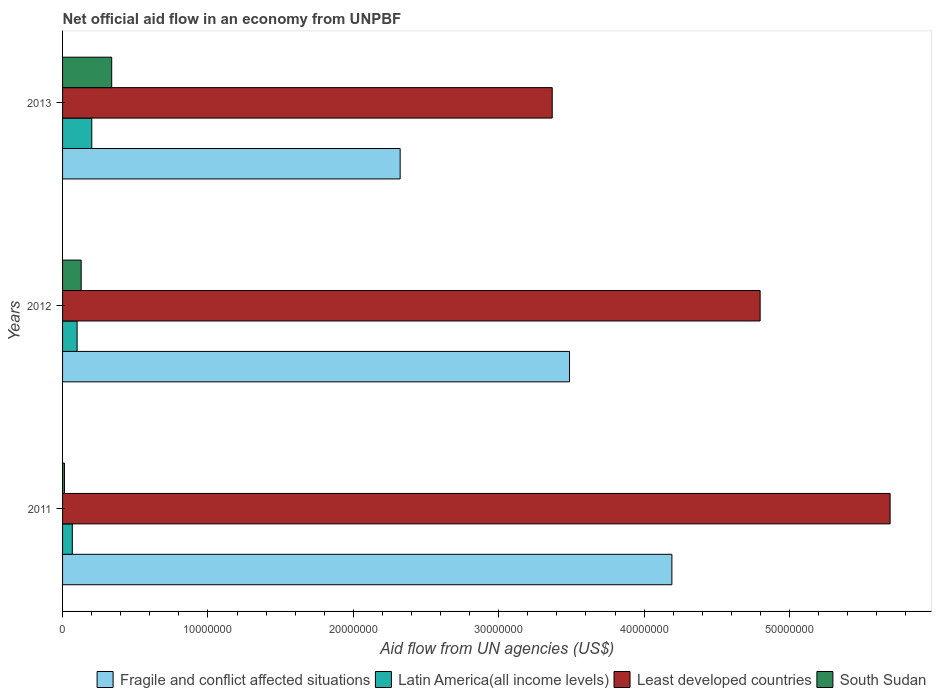Are the number of bars per tick equal to the number of legend labels?
Your answer should be compact. Yes. Are the number of bars on each tick of the Y-axis equal?
Provide a succinct answer. Yes. How many bars are there on the 2nd tick from the top?
Keep it short and to the point. 4. What is the label of the 2nd group of bars from the top?
Provide a short and direct response. 2012. In how many cases, is the number of bars for a given year not equal to the number of legend labels?
Provide a succinct answer. 0. What is the net official aid flow in Fragile and conflict affected situations in 2012?
Your answer should be very brief. 3.49e+07. Across all years, what is the maximum net official aid flow in South Sudan?
Provide a succinct answer. 3.38e+06. Across all years, what is the minimum net official aid flow in Fragile and conflict affected situations?
Your answer should be compact. 2.32e+07. In which year was the net official aid flow in South Sudan maximum?
Provide a succinct answer. 2013. In which year was the net official aid flow in Latin America(all income levels) minimum?
Keep it short and to the point. 2011. What is the total net official aid flow in South Sudan in the graph?
Make the answer very short. 4.79e+06. What is the difference between the net official aid flow in Fragile and conflict affected situations in 2011 and that in 2012?
Your response must be concise. 7.04e+06. What is the difference between the net official aid flow in Fragile and conflict affected situations in 2011 and the net official aid flow in Latin America(all income levels) in 2012?
Your answer should be compact. 4.09e+07. What is the average net official aid flow in Fragile and conflict affected situations per year?
Keep it short and to the point. 3.33e+07. In the year 2012, what is the difference between the net official aid flow in Least developed countries and net official aid flow in Latin America(all income levels)?
Your answer should be compact. 4.70e+07. What is the ratio of the net official aid flow in Latin America(all income levels) in 2012 to that in 2013?
Your answer should be compact. 0.5. What is the difference between the highest and the second highest net official aid flow in Latin America(all income levels)?
Ensure brevity in your answer.  1.01e+06. What is the difference between the highest and the lowest net official aid flow in Fragile and conflict affected situations?
Your answer should be very brief. 1.87e+07. In how many years, is the net official aid flow in Latin America(all income levels) greater than the average net official aid flow in Latin America(all income levels) taken over all years?
Your response must be concise. 1. Is it the case that in every year, the sum of the net official aid flow in Fragile and conflict affected situations and net official aid flow in South Sudan is greater than the sum of net official aid flow in Latin America(all income levels) and net official aid flow in Least developed countries?
Make the answer very short. Yes. What does the 2nd bar from the top in 2011 represents?
Offer a terse response. Least developed countries. What does the 1st bar from the bottom in 2012 represents?
Your answer should be compact. Fragile and conflict affected situations. Is it the case that in every year, the sum of the net official aid flow in Latin America(all income levels) and net official aid flow in South Sudan is greater than the net official aid flow in Fragile and conflict affected situations?
Your answer should be very brief. No. Are all the bars in the graph horizontal?
Ensure brevity in your answer.  Yes. What is the difference between two consecutive major ticks on the X-axis?
Offer a terse response. 1.00e+07. Are the values on the major ticks of X-axis written in scientific E-notation?
Give a very brief answer. No. Does the graph contain grids?
Offer a very short reply. No. Where does the legend appear in the graph?
Make the answer very short. Bottom right. How many legend labels are there?
Make the answer very short. 4. What is the title of the graph?
Provide a short and direct response. Net official aid flow in an economy from UNPBF. Does "Czech Republic" appear as one of the legend labels in the graph?
Your response must be concise. No. What is the label or title of the X-axis?
Provide a succinct answer. Aid flow from UN agencies (US$). What is the Aid flow from UN agencies (US$) in Fragile and conflict affected situations in 2011?
Your answer should be compact. 4.19e+07. What is the Aid flow from UN agencies (US$) in Latin America(all income levels) in 2011?
Provide a succinct answer. 6.70e+05. What is the Aid flow from UN agencies (US$) of Least developed countries in 2011?
Your answer should be compact. 5.69e+07. What is the Aid flow from UN agencies (US$) in Fragile and conflict affected situations in 2012?
Your response must be concise. 3.49e+07. What is the Aid flow from UN agencies (US$) in Least developed countries in 2012?
Offer a terse response. 4.80e+07. What is the Aid flow from UN agencies (US$) of South Sudan in 2012?
Provide a succinct answer. 1.28e+06. What is the Aid flow from UN agencies (US$) in Fragile and conflict affected situations in 2013?
Your answer should be very brief. 2.32e+07. What is the Aid flow from UN agencies (US$) of Latin America(all income levels) in 2013?
Ensure brevity in your answer.  2.01e+06. What is the Aid flow from UN agencies (US$) of Least developed countries in 2013?
Offer a terse response. 3.37e+07. What is the Aid flow from UN agencies (US$) in South Sudan in 2013?
Offer a terse response. 3.38e+06. Across all years, what is the maximum Aid flow from UN agencies (US$) of Fragile and conflict affected situations?
Give a very brief answer. 4.19e+07. Across all years, what is the maximum Aid flow from UN agencies (US$) in Latin America(all income levels)?
Make the answer very short. 2.01e+06. Across all years, what is the maximum Aid flow from UN agencies (US$) of Least developed countries?
Your response must be concise. 5.69e+07. Across all years, what is the maximum Aid flow from UN agencies (US$) of South Sudan?
Make the answer very short. 3.38e+06. Across all years, what is the minimum Aid flow from UN agencies (US$) of Fragile and conflict affected situations?
Your response must be concise. 2.32e+07. Across all years, what is the minimum Aid flow from UN agencies (US$) in Latin America(all income levels)?
Your answer should be very brief. 6.70e+05. Across all years, what is the minimum Aid flow from UN agencies (US$) in Least developed countries?
Offer a very short reply. 3.37e+07. Across all years, what is the minimum Aid flow from UN agencies (US$) of South Sudan?
Offer a very short reply. 1.30e+05. What is the total Aid flow from UN agencies (US$) of Fragile and conflict affected situations in the graph?
Offer a terse response. 1.00e+08. What is the total Aid flow from UN agencies (US$) in Latin America(all income levels) in the graph?
Provide a succinct answer. 3.68e+06. What is the total Aid flow from UN agencies (US$) in Least developed countries in the graph?
Keep it short and to the point. 1.39e+08. What is the total Aid flow from UN agencies (US$) in South Sudan in the graph?
Keep it short and to the point. 4.79e+06. What is the difference between the Aid flow from UN agencies (US$) in Fragile and conflict affected situations in 2011 and that in 2012?
Provide a succinct answer. 7.04e+06. What is the difference between the Aid flow from UN agencies (US$) in Latin America(all income levels) in 2011 and that in 2012?
Ensure brevity in your answer.  -3.30e+05. What is the difference between the Aid flow from UN agencies (US$) of Least developed countries in 2011 and that in 2012?
Your answer should be very brief. 8.94e+06. What is the difference between the Aid flow from UN agencies (US$) in South Sudan in 2011 and that in 2012?
Ensure brevity in your answer.  -1.15e+06. What is the difference between the Aid flow from UN agencies (US$) in Fragile and conflict affected situations in 2011 and that in 2013?
Provide a succinct answer. 1.87e+07. What is the difference between the Aid flow from UN agencies (US$) in Latin America(all income levels) in 2011 and that in 2013?
Make the answer very short. -1.34e+06. What is the difference between the Aid flow from UN agencies (US$) of Least developed countries in 2011 and that in 2013?
Ensure brevity in your answer.  2.32e+07. What is the difference between the Aid flow from UN agencies (US$) of South Sudan in 2011 and that in 2013?
Ensure brevity in your answer.  -3.25e+06. What is the difference between the Aid flow from UN agencies (US$) in Fragile and conflict affected situations in 2012 and that in 2013?
Ensure brevity in your answer.  1.16e+07. What is the difference between the Aid flow from UN agencies (US$) in Latin America(all income levels) in 2012 and that in 2013?
Your response must be concise. -1.01e+06. What is the difference between the Aid flow from UN agencies (US$) of Least developed countries in 2012 and that in 2013?
Give a very brief answer. 1.43e+07. What is the difference between the Aid flow from UN agencies (US$) of South Sudan in 2012 and that in 2013?
Provide a succinct answer. -2.10e+06. What is the difference between the Aid flow from UN agencies (US$) of Fragile and conflict affected situations in 2011 and the Aid flow from UN agencies (US$) of Latin America(all income levels) in 2012?
Make the answer very short. 4.09e+07. What is the difference between the Aid flow from UN agencies (US$) of Fragile and conflict affected situations in 2011 and the Aid flow from UN agencies (US$) of Least developed countries in 2012?
Provide a short and direct response. -6.07e+06. What is the difference between the Aid flow from UN agencies (US$) of Fragile and conflict affected situations in 2011 and the Aid flow from UN agencies (US$) of South Sudan in 2012?
Provide a short and direct response. 4.06e+07. What is the difference between the Aid flow from UN agencies (US$) in Latin America(all income levels) in 2011 and the Aid flow from UN agencies (US$) in Least developed countries in 2012?
Your answer should be very brief. -4.73e+07. What is the difference between the Aid flow from UN agencies (US$) in Latin America(all income levels) in 2011 and the Aid flow from UN agencies (US$) in South Sudan in 2012?
Your answer should be compact. -6.10e+05. What is the difference between the Aid flow from UN agencies (US$) in Least developed countries in 2011 and the Aid flow from UN agencies (US$) in South Sudan in 2012?
Keep it short and to the point. 5.56e+07. What is the difference between the Aid flow from UN agencies (US$) of Fragile and conflict affected situations in 2011 and the Aid flow from UN agencies (US$) of Latin America(all income levels) in 2013?
Your answer should be compact. 3.99e+07. What is the difference between the Aid flow from UN agencies (US$) in Fragile and conflict affected situations in 2011 and the Aid flow from UN agencies (US$) in Least developed countries in 2013?
Your response must be concise. 8.23e+06. What is the difference between the Aid flow from UN agencies (US$) of Fragile and conflict affected situations in 2011 and the Aid flow from UN agencies (US$) of South Sudan in 2013?
Provide a succinct answer. 3.85e+07. What is the difference between the Aid flow from UN agencies (US$) in Latin America(all income levels) in 2011 and the Aid flow from UN agencies (US$) in Least developed countries in 2013?
Provide a short and direct response. -3.30e+07. What is the difference between the Aid flow from UN agencies (US$) in Latin America(all income levels) in 2011 and the Aid flow from UN agencies (US$) in South Sudan in 2013?
Your answer should be compact. -2.71e+06. What is the difference between the Aid flow from UN agencies (US$) of Least developed countries in 2011 and the Aid flow from UN agencies (US$) of South Sudan in 2013?
Provide a succinct answer. 5.35e+07. What is the difference between the Aid flow from UN agencies (US$) in Fragile and conflict affected situations in 2012 and the Aid flow from UN agencies (US$) in Latin America(all income levels) in 2013?
Make the answer very short. 3.29e+07. What is the difference between the Aid flow from UN agencies (US$) in Fragile and conflict affected situations in 2012 and the Aid flow from UN agencies (US$) in Least developed countries in 2013?
Give a very brief answer. 1.19e+06. What is the difference between the Aid flow from UN agencies (US$) of Fragile and conflict affected situations in 2012 and the Aid flow from UN agencies (US$) of South Sudan in 2013?
Your response must be concise. 3.15e+07. What is the difference between the Aid flow from UN agencies (US$) of Latin America(all income levels) in 2012 and the Aid flow from UN agencies (US$) of Least developed countries in 2013?
Keep it short and to the point. -3.27e+07. What is the difference between the Aid flow from UN agencies (US$) of Latin America(all income levels) in 2012 and the Aid flow from UN agencies (US$) of South Sudan in 2013?
Ensure brevity in your answer.  -2.38e+06. What is the difference between the Aid flow from UN agencies (US$) of Least developed countries in 2012 and the Aid flow from UN agencies (US$) of South Sudan in 2013?
Your response must be concise. 4.46e+07. What is the average Aid flow from UN agencies (US$) in Fragile and conflict affected situations per year?
Offer a very short reply. 3.33e+07. What is the average Aid flow from UN agencies (US$) of Latin America(all income levels) per year?
Make the answer very short. 1.23e+06. What is the average Aid flow from UN agencies (US$) of Least developed countries per year?
Ensure brevity in your answer.  4.62e+07. What is the average Aid flow from UN agencies (US$) of South Sudan per year?
Ensure brevity in your answer.  1.60e+06. In the year 2011, what is the difference between the Aid flow from UN agencies (US$) in Fragile and conflict affected situations and Aid flow from UN agencies (US$) in Latin America(all income levels)?
Your answer should be very brief. 4.12e+07. In the year 2011, what is the difference between the Aid flow from UN agencies (US$) in Fragile and conflict affected situations and Aid flow from UN agencies (US$) in Least developed countries?
Your answer should be compact. -1.50e+07. In the year 2011, what is the difference between the Aid flow from UN agencies (US$) of Fragile and conflict affected situations and Aid flow from UN agencies (US$) of South Sudan?
Your answer should be very brief. 4.18e+07. In the year 2011, what is the difference between the Aid flow from UN agencies (US$) in Latin America(all income levels) and Aid flow from UN agencies (US$) in Least developed countries?
Your response must be concise. -5.62e+07. In the year 2011, what is the difference between the Aid flow from UN agencies (US$) in Latin America(all income levels) and Aid flow from UN agencies (US$) in South Sudan?
Offer a terse response. 5.40e+05. In the year 2011, what is the difference between the Aid flow from UN agencies (US$) of Least developed countries and Aid flow from UN agencies (US$) of South Sudan?
Your answer should be very brief. 5.68e+07. In the year 2012, what is the difference between the Aid flow from UN agencies (US$) of Fragile and conflict affected situations and Aid flow from UN agencies (US$) of Latin America(all income levels)?
Make the answer very short. 3.39e+07. In the year 2012, what is the difference between the Aid flow from UN agencies (US$) of Fragile and conflict affected situations and Aid flow from UN agencies (US$) of Least developed countries?
Your answer should be very brief. -1.31e+07. In the year 2012, what is the difference between the Aid flow from UN agencies (US$) of Fragile and conflict affected situations and Aid flow from UN agencies (US$) of South Sudan?
Your response must be concise. 3.36e+07. In the year 2012, what is the difference between the Aid flow from UN agencies (US$) in Latin America(all income levels) and Aid flow from UN agencies (US$) in Least developed countries?
Ensure brevity in your answer.  -4.70e+07. In the year 2012, what is the difference between the Aid flow from UN agencies (US$) of Latin America(all income levels) and Aid flow from UN agencies (US$) of South Sudan?
Your response must be concise. -2.80e+05. In the year 2012, what is the difference between the Aid flow from UN agencies (US$) in Least developed countries and Aid flow from UN agencies (US$) in South Sudan?
Give a very brief answer. 4.67e+07. In the year 2013, what is the difference between the Aid flow from UN agencies (US$) of Fragile and conflict affected situations and Aid flow from UN agencies (US$) of Latin America(all income levels)?
Your response must be concise. 2.12e+07. In the year 2013, what is the difference between the Aid flow from UN agencies (US$) in Fragile and conflict affected situations and Aid flow from UN agencies (US$) in Least developed countries?
Ensure brevity in your answer.  -1.05e+07. In the year 2013, what is the difference between the Aid flow from UN agencies (US$) of Fragile and conflict affected situations and Aid flow from UN agencies (US$) of South Sudan?
Make the answer very short. 1.98e+07. In the year 2013, what is the difference between the Aid flow from UN agencies (US$) of Latin America(all income levels) and Aid flow from UN agencies (US$) of Least developed countries?
Your response must be concise. -3.17e+07. In the year 2013, what is the difference between the Aid flow from UN agencies (US$) in Latin America(all income levels) and Aid flow from UN agencies (US$) in South Sudan?
Provide a short and direct response. -1.37e+06. In the year 2013, what is the difference between the Aid flow from UN agencies (US$) of Least developed countries and Aid flow from UN agencies (US$) of South Sudan?
Your response must be concise. 3.03e+07. What is the ratio of the Aid flow from UN agencies (US$) of Fragile and conflict affected situations in 2011 to that in 2012?
Provide a short and direct response. 1.2. What is the ratio of the Aid flow from UN agencies (US$) of Latin America(all income levels) in 2011 to that in 2012?
Keep it short and to the point. 0.67. What is the ratio of the Aid flow from UN agencies (US$) in Least developed countries in 2011 to that in 2012?
Provide a succinct answer. 1.19. What is the ratio of the Aid flow from UN agencies (US$) in South Sudan in 2011 to that in 2012?
Offer a terse response. 0.1. What is the ratio of the Aid flow from UN agencies (US$) in Fragile and conflict affected situations in 2011 to that in 2013?
Your response must be concise. 1.8. What is the ratio of the Aid flow from UN agencies (US$) of Latin America(all income levels) in 2011 to that in 2013?
Your answer should be compact. 0.33. What is the ratio of the Aid flow from UN agencies (US$) of Least developed countries in 2011 to that in 2013?
Provide a short and direct response. 1.69. What is the ratio of the Aid flow from UN agencies (US$) in South Sudan in 2011 to that in 2013?
Keep it short and to the point. 0.04. What is the ratio of the Aid flow from UN agencies (US$) in Fragile and conflict affected situations in 2012 to that in 2013?
Provide a short and direct response. 1.5. What is the ratio of the Aid flow from UN agencies (US$) of Latin America(all income levels) in 2012 to that in 2013?
Give a very brief answer. 0.5. What is the ratio of the Aid flow from UN agencies (US$) of Least developed countries in 2012 to that in 2013?
Offer a terse response. 1.42. What is the ratio of the Aid flow from UN agencies (US$) in South Sudan in 2012 to that in 2013?
Your answer should be compact. 0.38. What is the difference between the highest and the second highest Aid flow from UN agencies (US$) in Fragile and conflict affected situations?
Offer a terse response. 7.04e+06. What is the difference between the highest and the second highest Aid flow from UN agencies (US$) in Latin America(all income levels)?
Your answer should be very brief. 1.01e+06. What is the difference between the highest and the second highest Aid flow from UN agencies (US$) of Least developed countries?
Keep it short and to the point. 8.94e+06. What is the difference between the highest and the second highest Aid flow from UN agencies (US$) in South Sudan?
Provide a short and direct response. 2.10e+06. What is the difference between the highest and the lowest Aid flow from UN agencies (US$) in Fragile and conflict affected situations?
Your answer should be very brief. 1.87e+07. What is the difference between the highest and the lowest Aid flow from UN agencies (US$) in Latin America(all income levels)?
Keep it short and to the point. 1.34e+06. What is the difference between the highest and the lowest Aid flow from UN agencies (US$) in Least developed countries?
Your answer should be very brief. 2.32e+07. What is the difference between the highest and the lowest Aid flow from UN agencies (US$) of South Sudan?
Keep it short and to the point. 3.25e+06. 